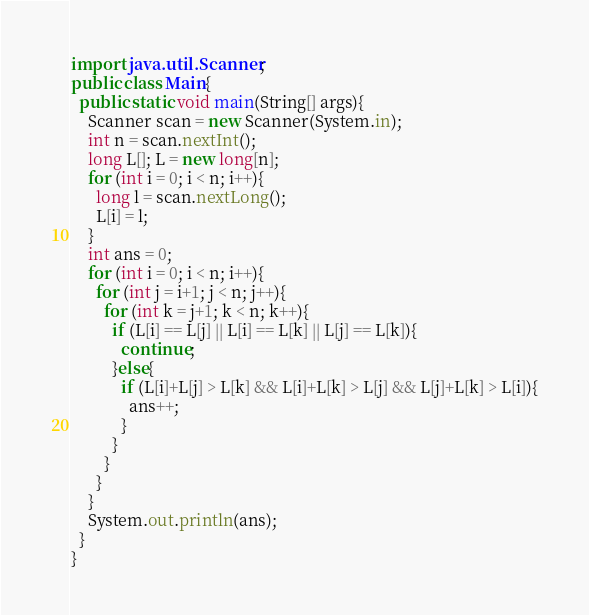<code> <loc_0><loc_0><loc_500><loc_500><_Java_>import java.util.Scanner;
public class Main{
  public static void main(String[] args){
    Scanner scan = new Scanner(System.in);
    int n = scan.nextInt();
    long L[]; L = new long[n];
    for (int i = 0; i < n; i++){
      long l = scan.nextLong();
      L[i] = l;
    }
    int ans = 0;
    for (int i = 0; i < n; i++){
      for (int j = i+1; j < n; j++){
        for (int k = j+1; k < n; k++){
          if (L[i] == L[j] || L[i] == L[k] || L[j] == L[k]){
            continue;
          }else{
            if (L[i]+L[j] > L[k] && L[i]+L[k] > L[j] && L[j]+L[k] > L[i]){
              ans++;
            }
          }
        }
      }
    }
    System.out.println(ans);
  }
}
</code> 